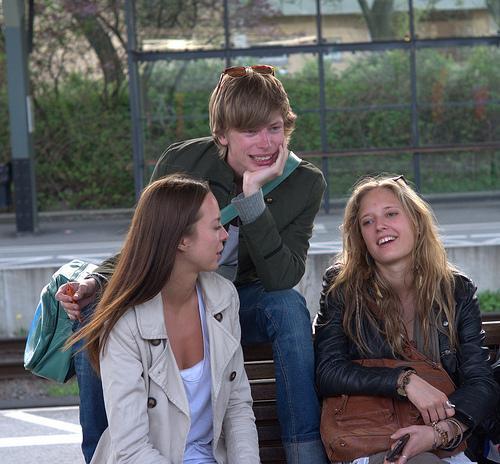How many females in the picture?
Give a very brief answer. 2. 